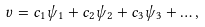<formula> <loc_0><loc_0><loc_500><loc_500>v = c _ { 1 } \psi _ { 1 } + c _ { 2 } \psi _ { 2 } + c _ { 3 } \psi _ { 3 } + \dots ,</formula> 